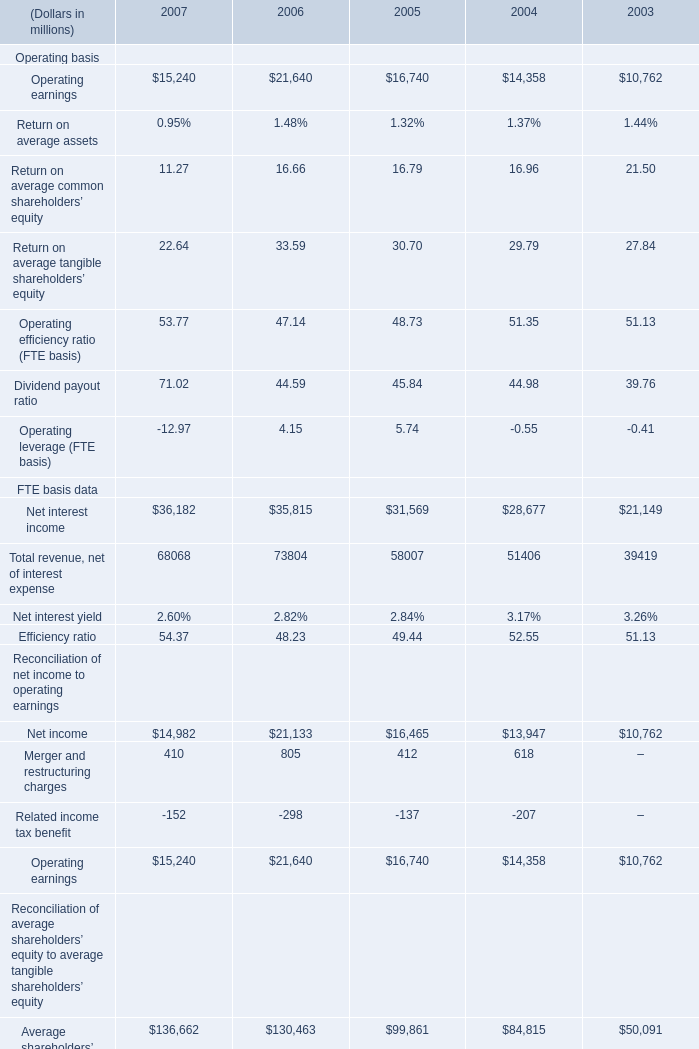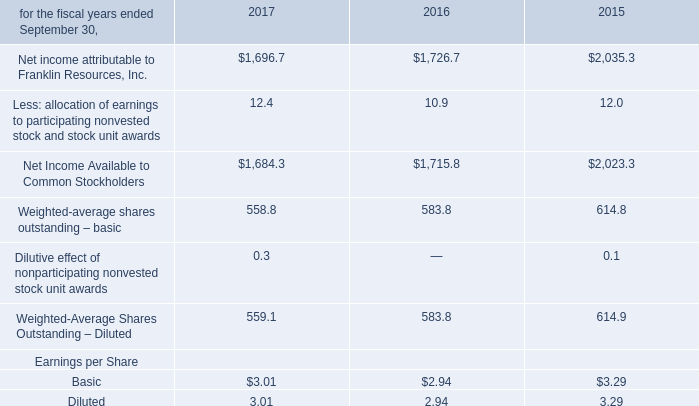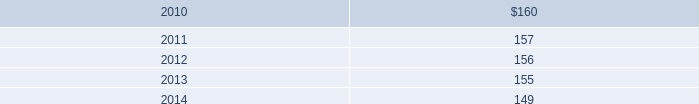What's the total amount of Operating earnings excluding those negative ones in 2007? (in millions) 
Computations: (14982 + 410)
Answer: 15392.0. 